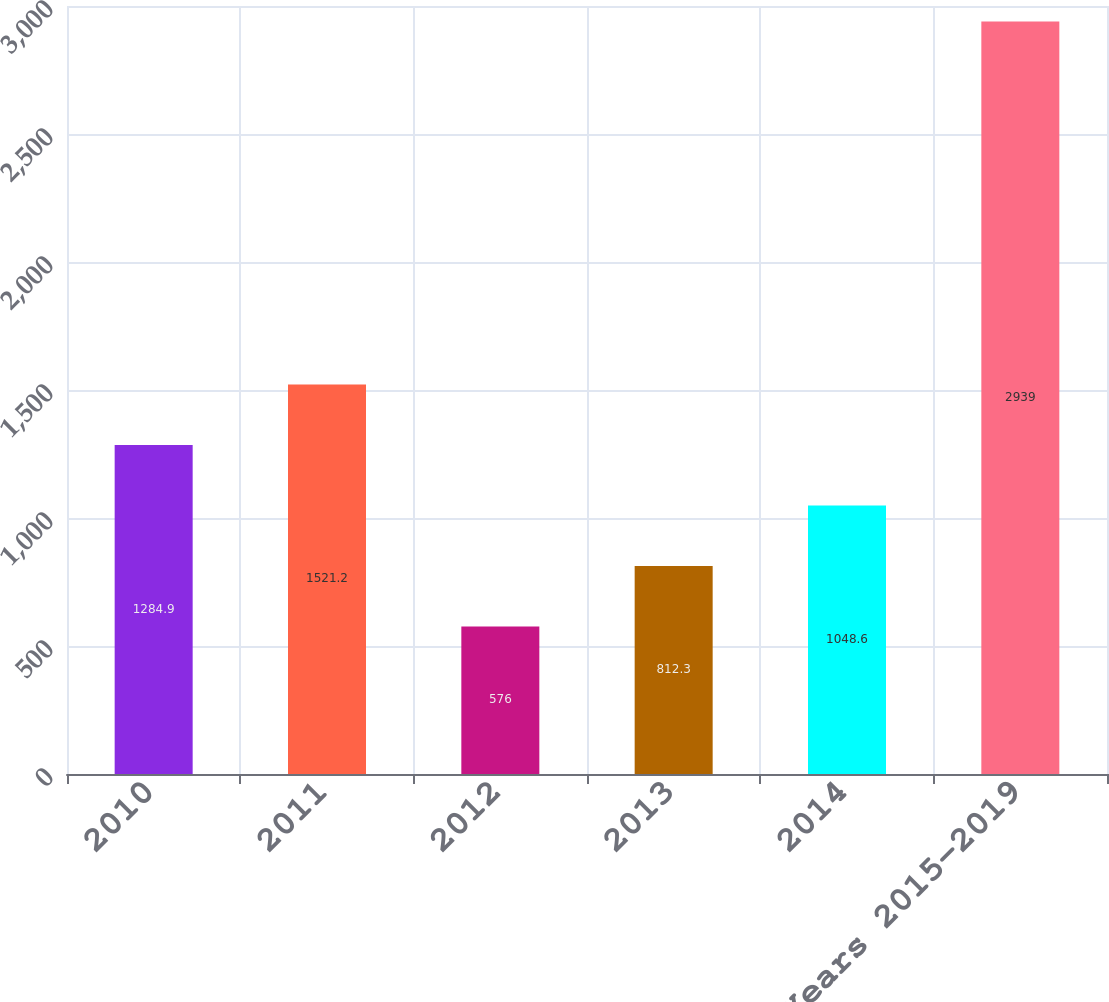Convert chart to OTSL. <chart><loc_0><loc_0><loc_500><loc_500><bar_chart><fcel>2010<fcel>2011<fcel>2012<fcel>2013<fcel>2014<fcel>Years 2015-2019<nl><fcel>1284.9<fcel>1521.2<fcel>576<fcel>812.3<fcel>1048.6<fcel>2939<nl></chart> 